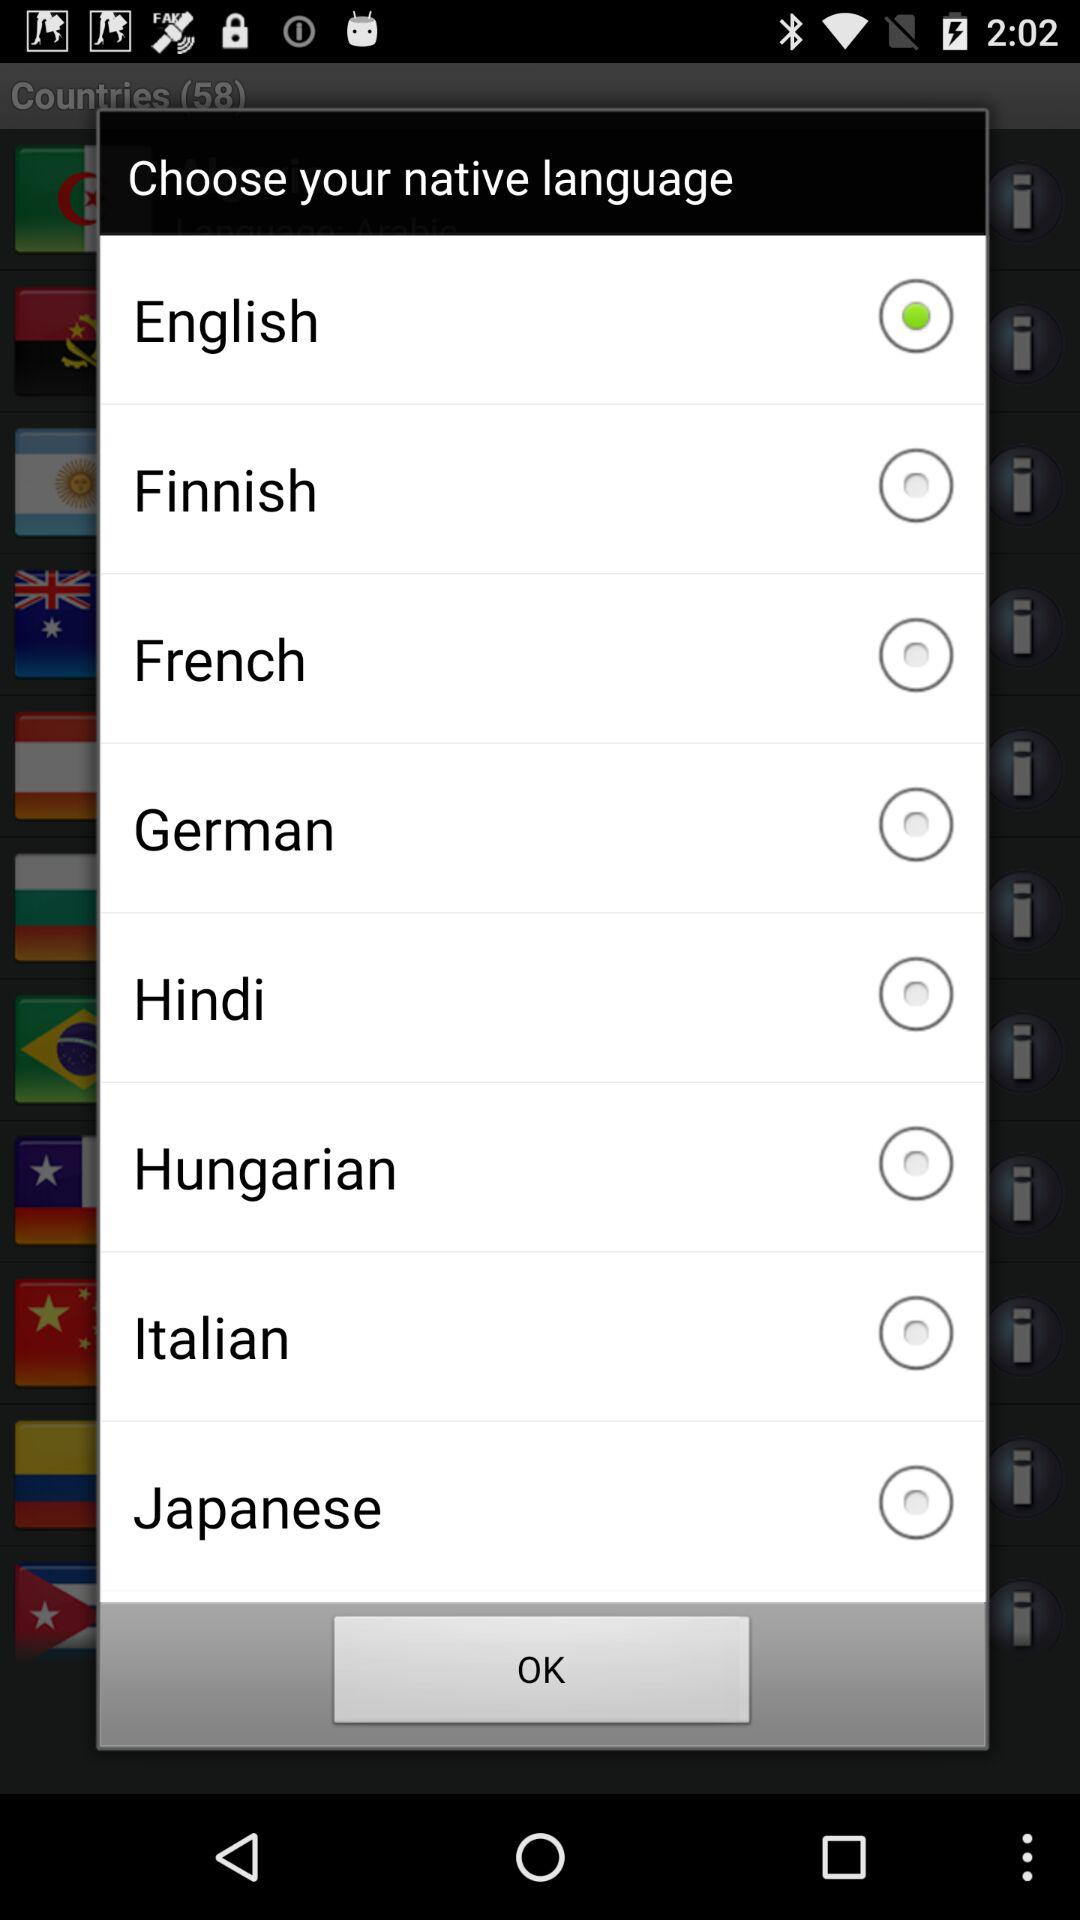Is "German" selected or not? "German" is not selected. 